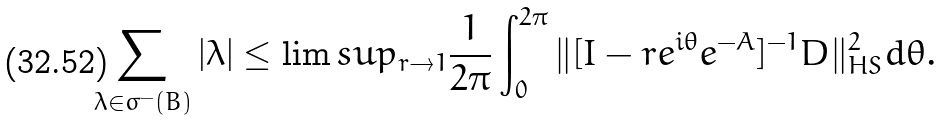<formula> <loc_0><loc_0><loc_500><loc_500>\sum _ { \lambda \in \sigma ^ { - } ( B ) } | \lambda | \leq \lim s u p _ { r \rightarrow 1 } \frac { 1 } { 2 \pi } \int _ { 0 } ^ { 2 \pi } \| [ I - r e ^ { i \theta } e ^ { - A } ] ^ { - 1 } D \| _ { H S } ^ { 2 } d \theta .</formula> 